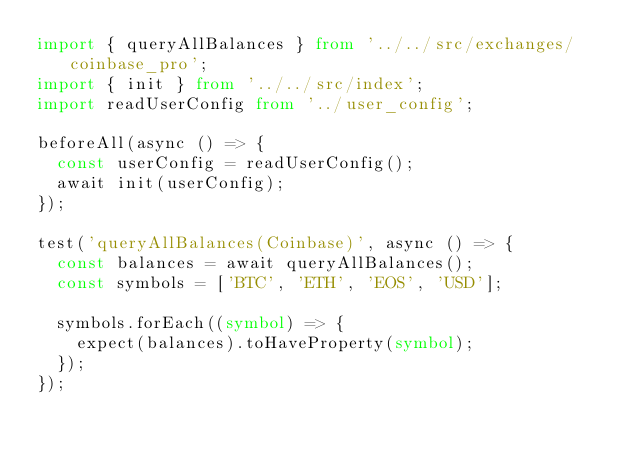<code> <loc_0><loc_0><loc_500><loc_500><_TypeScript_>import { queryAllBalances } from '../../src/exchanges/coinbase_pro';
import { init } from '../../src/index';
import readUserConfig from '../user_config';

beforeAll(async () => {
  const userConfig = readUserConfig();
  await init(userConfig);
});

test('queryAllBalances(Coinbase)', async () => {
  const balances = await queryAllBalances();
  const symbols = ['BTC', 'ETH', 'EOS', 'USD'];

  symbols.forEach((symbol) => {
    expect(balances).toHaveProperty(symbol);
  });
});
</code> 